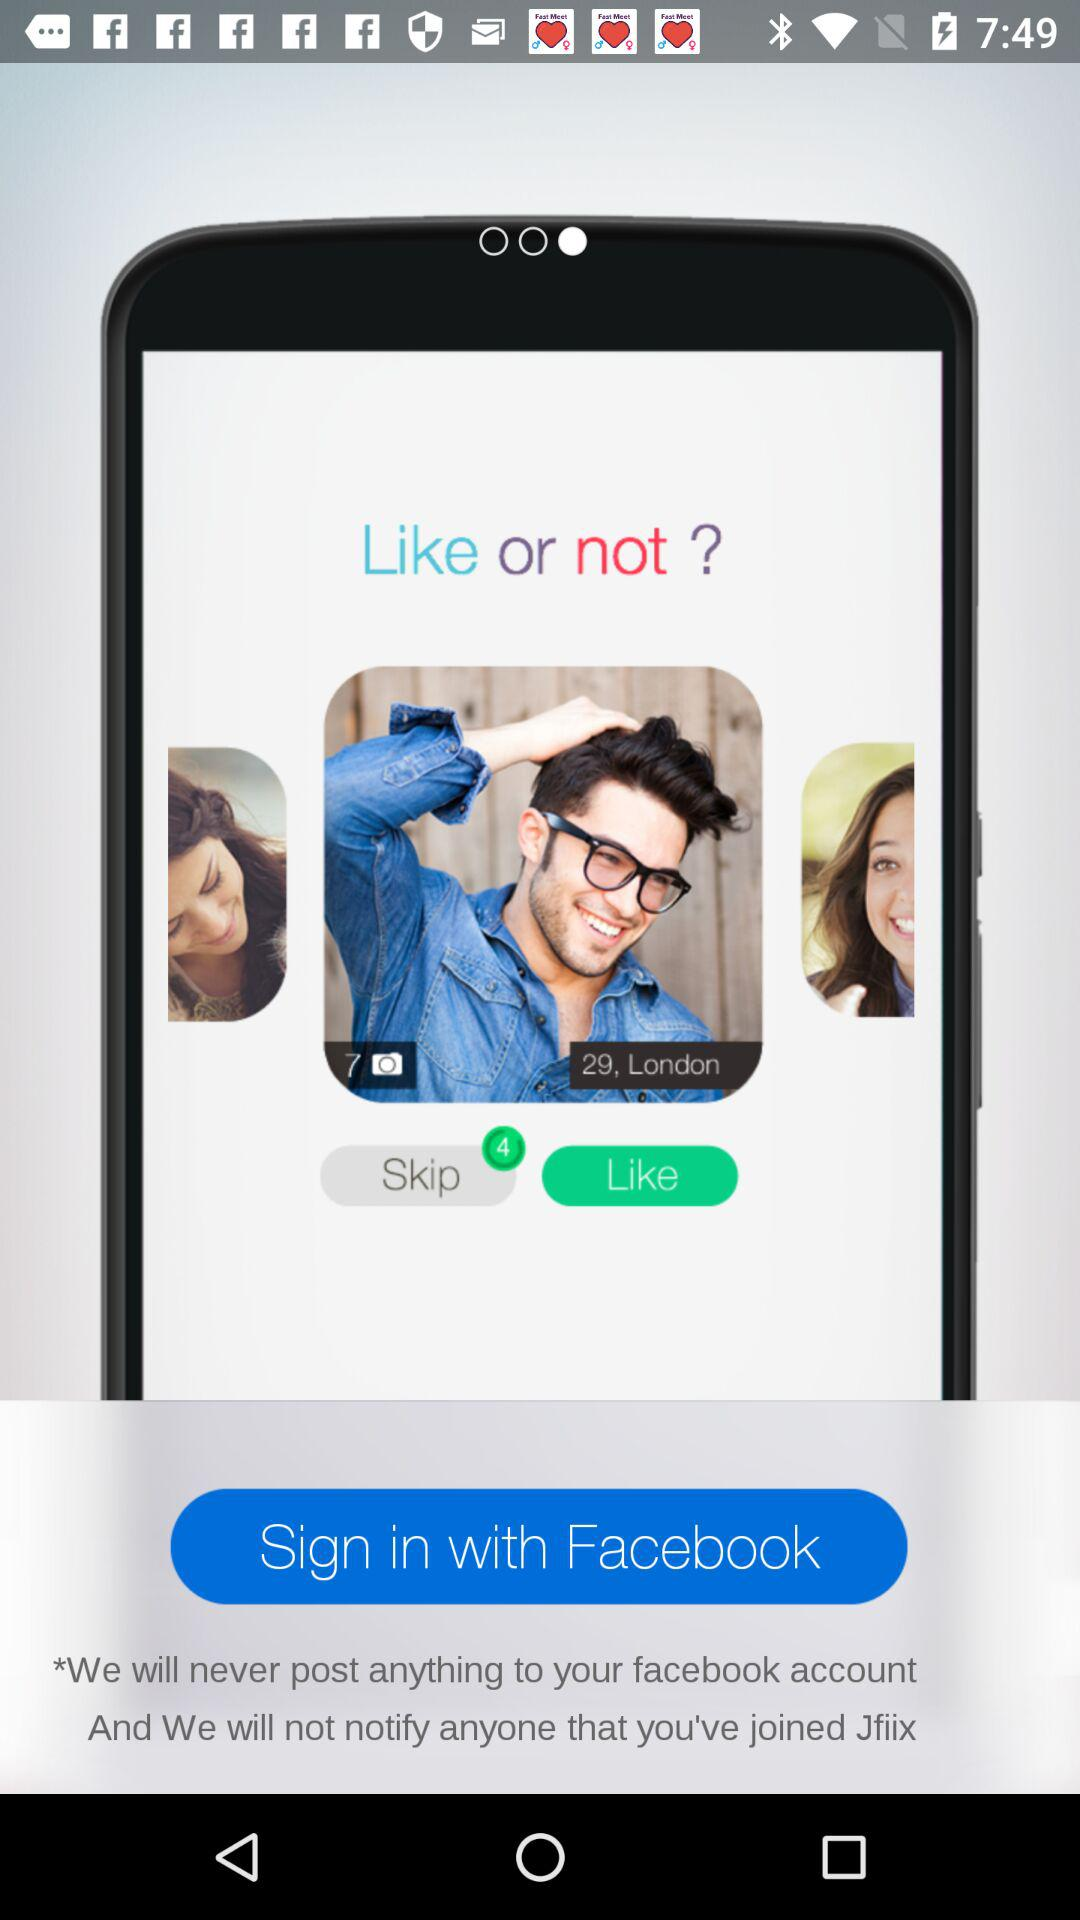Through what application can we sign in? You can sign in through "Facebook". 